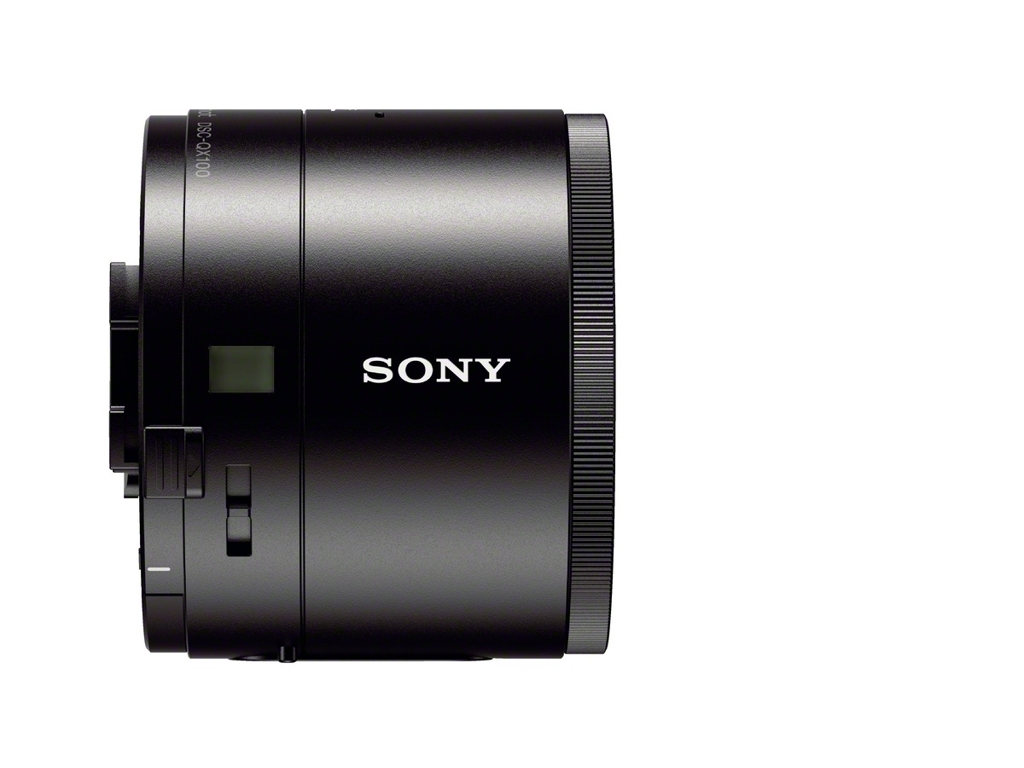Can you tell me what this device is? The device in the image appears to be an electronic lens, possibly for a camera, from the manufacturer SONY. 